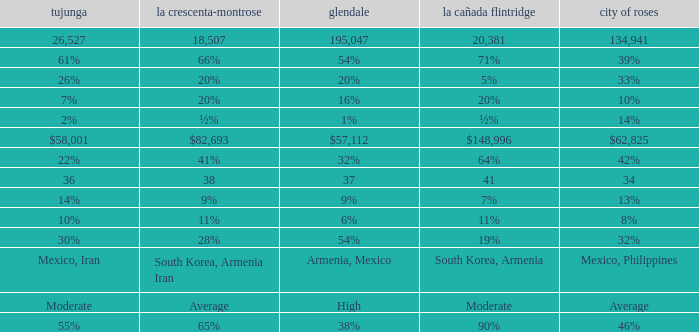What is the percentage of Tujunja when Pasadena is 33%? 26%. 